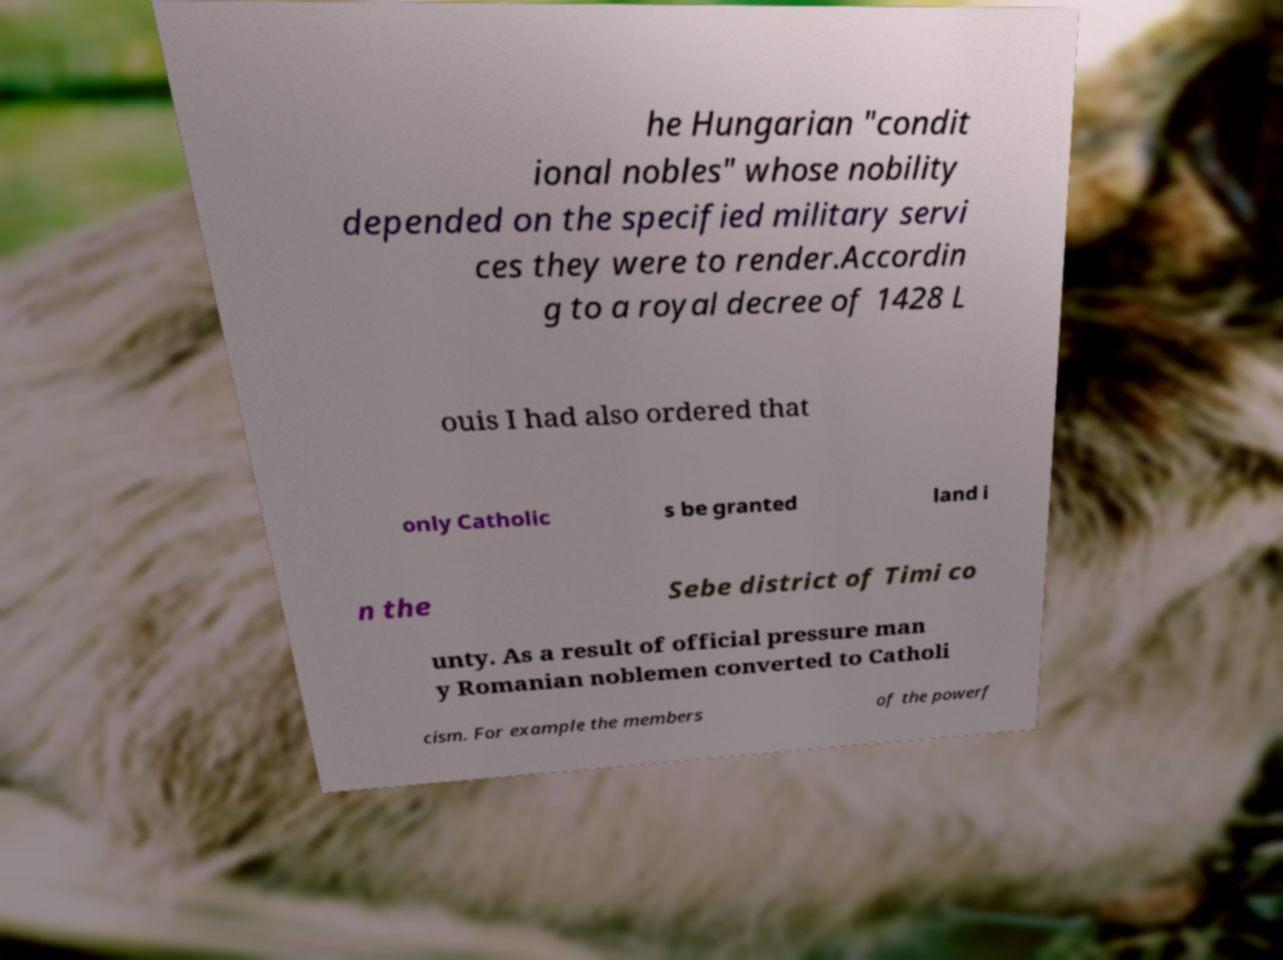Please identify and transcribe the text found in this image. he Hungarian "condit ional nobles" whose nobility depended on the specified military servi ces they were to render.Accordin g to a royal decree of 1428 L ouis I had also ordered that only Catholic s be granted land i n the Sebe district of Timi co unty. As a result of official pressure man y Romanian noblemen converted to Catholi cism. For example the members of the powerf 